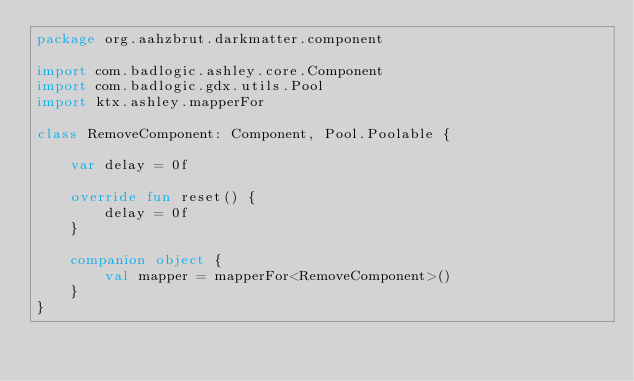<code> <loc_0><loc_0><loc_500><loc_500><_Kotlin_>package org.aahzbrut.darkmatter.component

import com.badlogic.ashley.core.Component
import com.badlogic.gdx.utils.Pool
import ktx.ashley.mapperFor

class RemoveComponent: Component, Pool.Poolable {

    var delay = 0f

    override fun reset() {
        delay = 0f
    }

    companion object {
        val mapper = mapperFor<RemoveComponent>()
    }
}</code> 